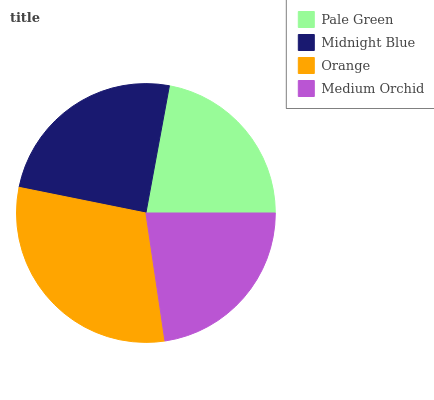Is Pale Green the minimum?
Answer yes or no. Yes. Is Orange the maximum?
Answer yes or no. Yes. Is Midnight Blue the minimum?
Answer yes or no. No. Is Midnight Blue the maximum?
Answer yes or no. No. Is Midnight Blue greater than Pale Green?
Answer yes or no. Yes. Is Pale Green less than Midnight Blue?
Answer yes or no. Yes. Is Pale Green greater than Midnight Blue?
Answer yes or no. No. Is Midnight Blue less than Pale Green?
Answer yes or no. No. Is Midnight Blue the high median?
Answer yes or no. Yes. Is Medium Orchid the low median?
Answer yes or no. Yes. Is Orange the high median?
Answer yes or no. No. Is Orange the low median?
Answer yes or no. No. 